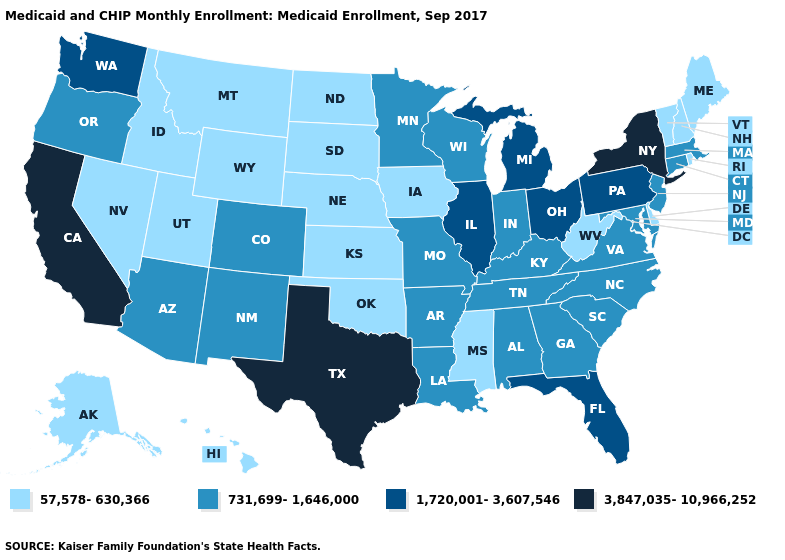Does Rhode Island have the same value as Tennessee?
Write a very short answer. No. What is the value of Connecticut?
Quick response, please. 731,699-1,646,000. What is the value of New Mexico?
Answer briefly. 731,699-1,646,000. What is the lowest value in the South?
Be succinct. 57,578-630,366. What is the value of Vermont?
Answer briefly. 57,578-630,366. What is the value of Kansas?
Be succinct. 57,578-630,366. Does Connecticut have a lower value than Texas?
Concise answer only. Yes. Is the legend a continuous bar?
Short answer required. No. Does Vermont have a lower value than Nebraska?
Be succinct. No. What is the value of Florida?
Answer briefly. 1,720,001-3,607,546. What is the highest value in the USA?
Quick response, please. 3,847,035-10,966,252. What is the lowest value in the USA?
Keep it brief. 57,578-630,366. What is the value of Massachusetts?
Concise answer only. 731,699-1,646,000. Which states hav the highest value in the West?
Be succinct. California. What is the value of South Dakota?
Keep it brief. 57,578-630,366. 